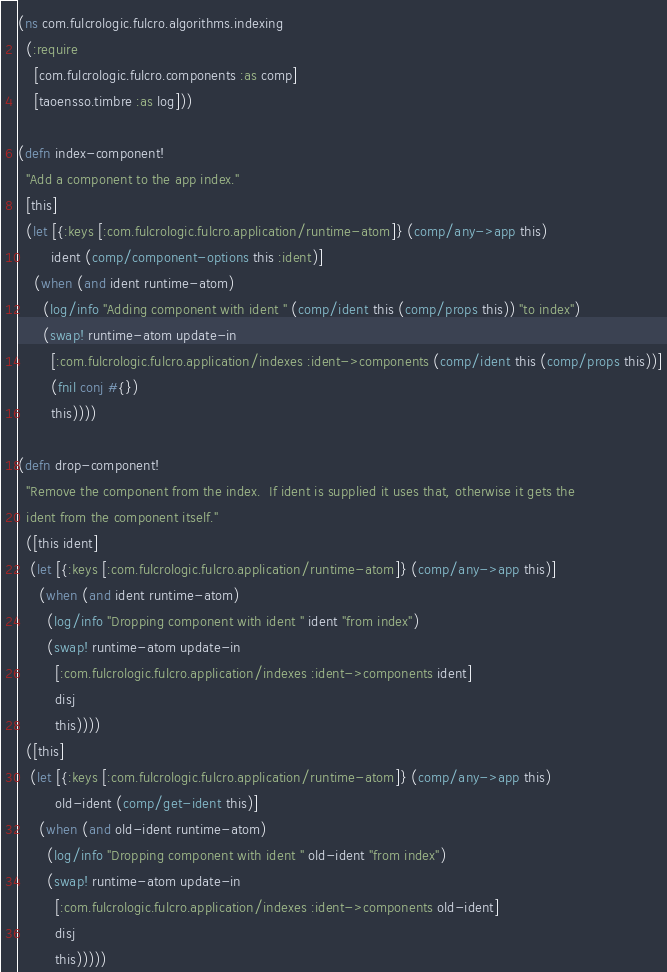<code> <loc_0><loc_0><loc_500><loc_500><_Clojure_>(ns com.fulcrologic.fulcro.algorithms.indexing
  (:require
    [com.fulcrologic.fulcro.components :as comp]
    [taoensso.timbre :as log]))

(defn index-component!
  "Add a component to the app index."
  [this]
  (let [{:keys [:com.fulcrologic.fulcro.application/runtime-atom]} (comp/any->app this)
        ident (comp/component-options this :ident)]
    (when (and ident runtime-atom)
      (log/info "Adding component with ident " (comp/ident this (comp/props this)) "to index")
      (swap! runtime-atom update-in
        [:com.fulcrologic.fulcro.application/indexes :ident->components (comp/ident this (comp/props this))]
        (fnil conj #{})
        this))))

(defn drop-component!
  "Remove the component from the index.  If ident is supplied it uses that, otherwise it gets the
  ident from the component itself."
  ([this ident]
   (let [{:keys [:com.fulcrologic.fulcro.application/runtime-atom]} (comp/any->app this)]
     (when (and ident runtime-atom)
       (log/info "Dropping component with ident " ident "from index")
       (swap! runtime-atom update-in
         [:com.fulcrologic.fulcro.application/indexes :ident->components ident]
         disj
         this))))
  ([this]
   (let [{:keys [:com.fulcrologic.fulcro.application/runtime-atom]} (comp/any->app this)
         old-ident (comp/get-ident this)]
     (when (and old-ident runtime-atom)
       (log/info "Dropping component with ident " old-ident "from index")
       (swap! runtime-atom update-in
         [:com.fulcrologic.fulcro.application/indexes :ident->components old-ident]
         disj
         this)))))
</code> 